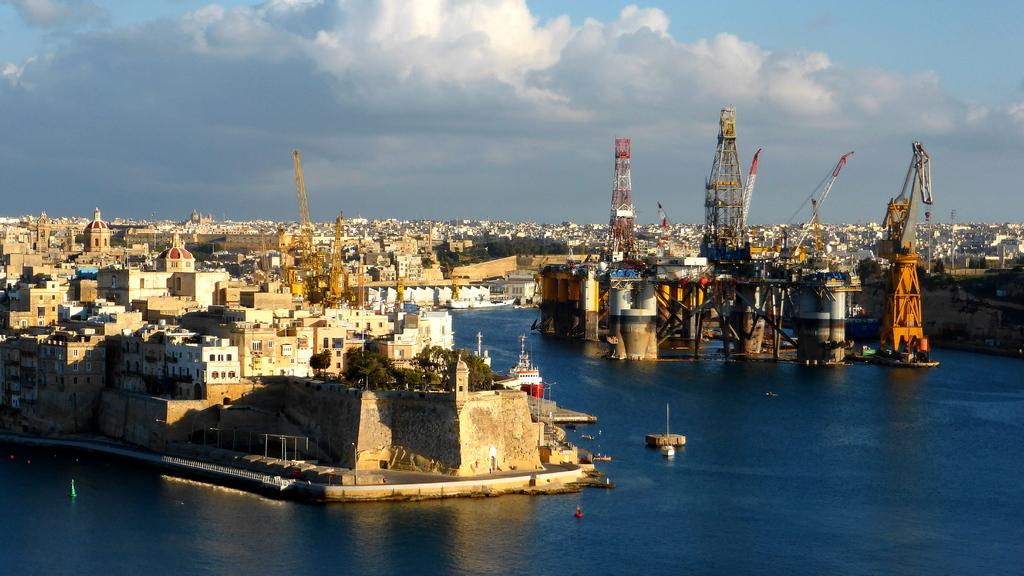What type of structures can be seen in the image? There are buildings in the image. What natural feature is visible at the bottom of the image? There is a river visible at the bottom of the image. What can be seen in the sky in the background of the image? There are clouds in the sky in the background of the image. Are there any dinosaurs visible in the image? No, there are no dinosaurs present in the image. What type of pet can be seen in the image? There is no pet visible in the image. 